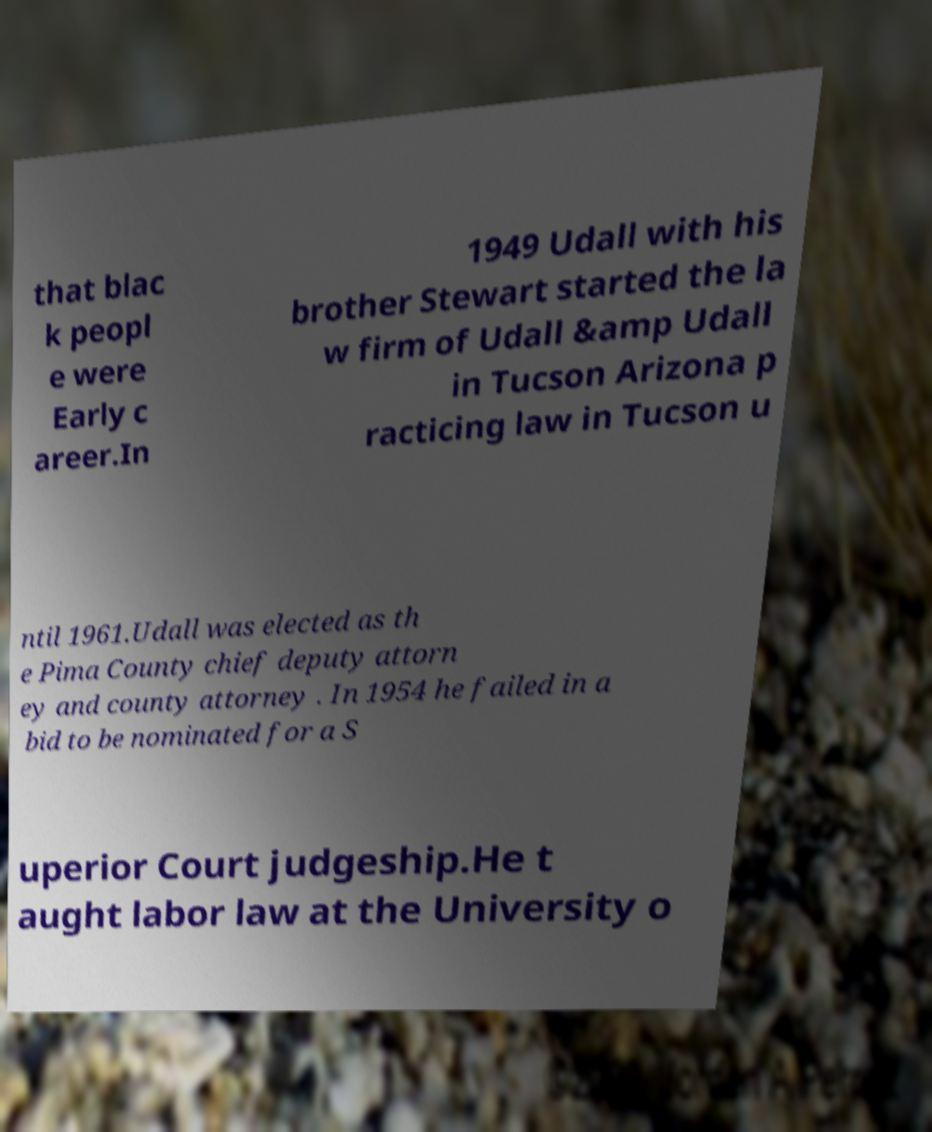For documentation purposes, I need the text within this image transcribed. Could you provide that? that blac k peopl e were Early c areer.In 1949 Udall with his brother Stewart started the la w firm of Udall &amp Udall in Tucson Arizona p racticing law in Tucson u ntil 1961.Udall was elected as th e Pima County chief deputy attorn ey and county attorney . In 1954 he failed in a bid to be nominated for a S uperior Court judgeship.He t aught labor law at the University o 